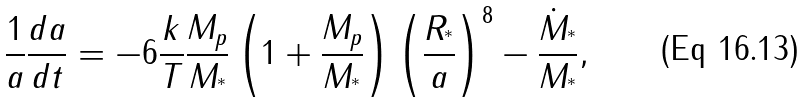<formula> <loc_0><loc_0><loc_500><loc_500>\frac { 1 } { a } \frac { d a } { d t } = - 6 \frac { k } { T } \frac { M _ { p } } { M _ { ^ { * } } } \left ( 1 + \frac { M _ { p } } { M _ { ^ { * } } } \right ) \left ( \frac { R _ { ^ { * } } } { a } \right ) ^ { 8 } - \frac { \dot { M } _ { ^ { * } } } { M _ { ^ { * } } } ,</formula> 